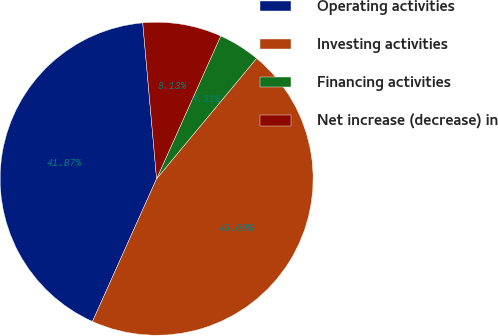<chart> <loc_0><loc_0><loc_500><loc_500><pie_chart><fcel>Operating activities<fcel>Investing activities<fcel>Financing activities<fcel>Net increase (decrease) in<nl><fcel>41.87%<fcel>45.69%<fcel>4.31%<fcel>8.13%<nl></chart> 